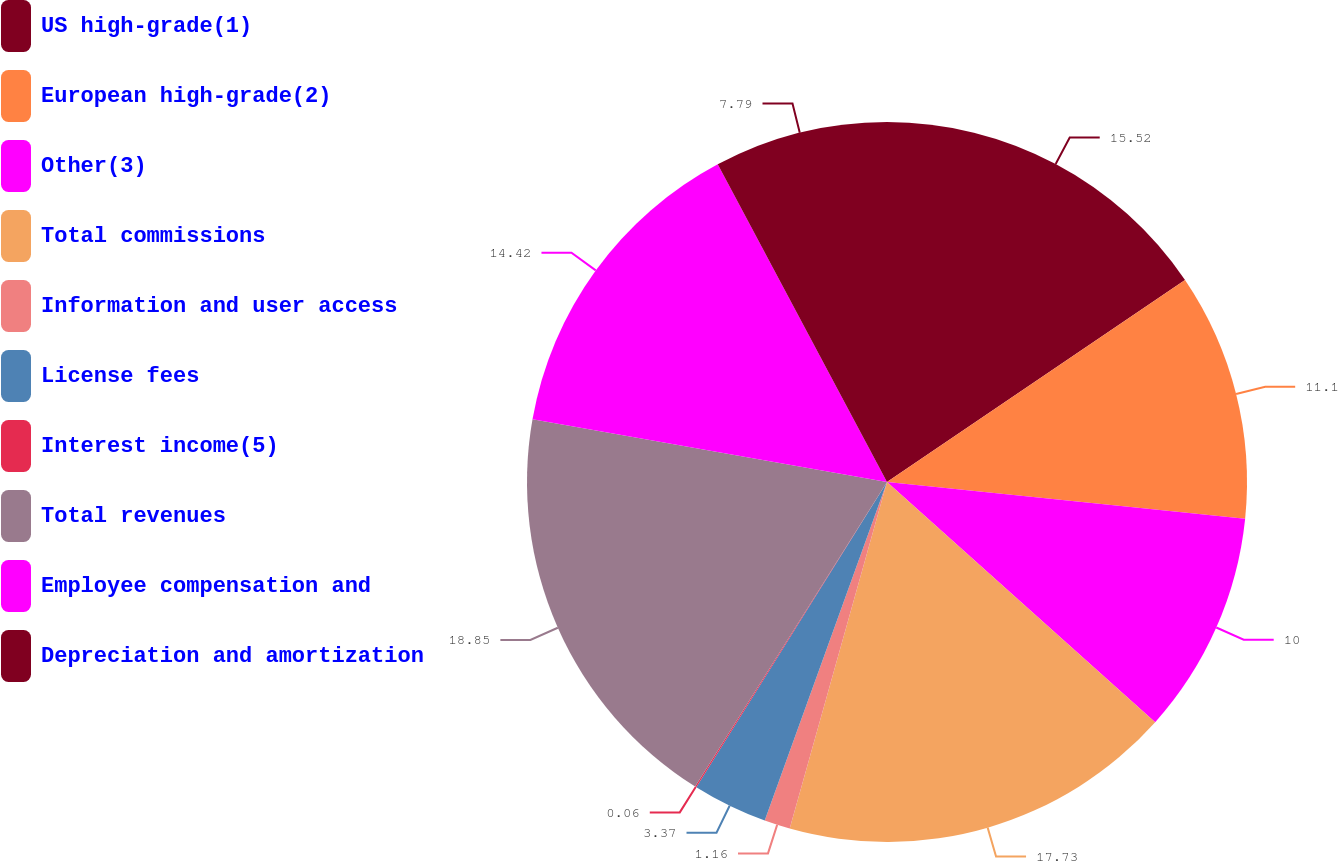Convert chart. <chart><loc_0><loc_0><loc_500><loc_500><pie_chart><fcel>US high-grade(1)<fcel>European high-grade(2)<fcel>Other(3)<fcel>Total commissions<fcel>Information and user access<fcel>License fees<fcel>Interest income(5)<fcel>Total revenues<fcel>Employee compensation and<fcel>Depreciation and amortization<nl><fcel>15.52%<fcel>11.1%<fcel>10.0%<fcel>17.73%<fcel>1.16%<fcel>3.37%<fcel>0.06%<fcel>18.84%<fcel>14.42%<fcel>7.79%<nl></chart> 